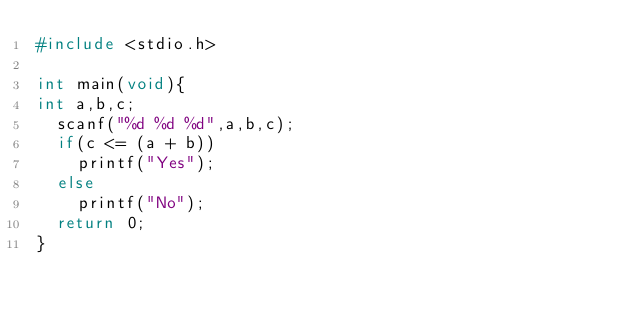Convert code to text. <code><loc_0><loc_0><loc_500><loc_500><_C_>#include <stdio.h>

int main(void){
int a,b,c;
  scanf("%d %d %d",a,b,c);
  if(c <= (a + b))
    printf("Yes");
  else
    printf("No");
  return 0;
}</code> 